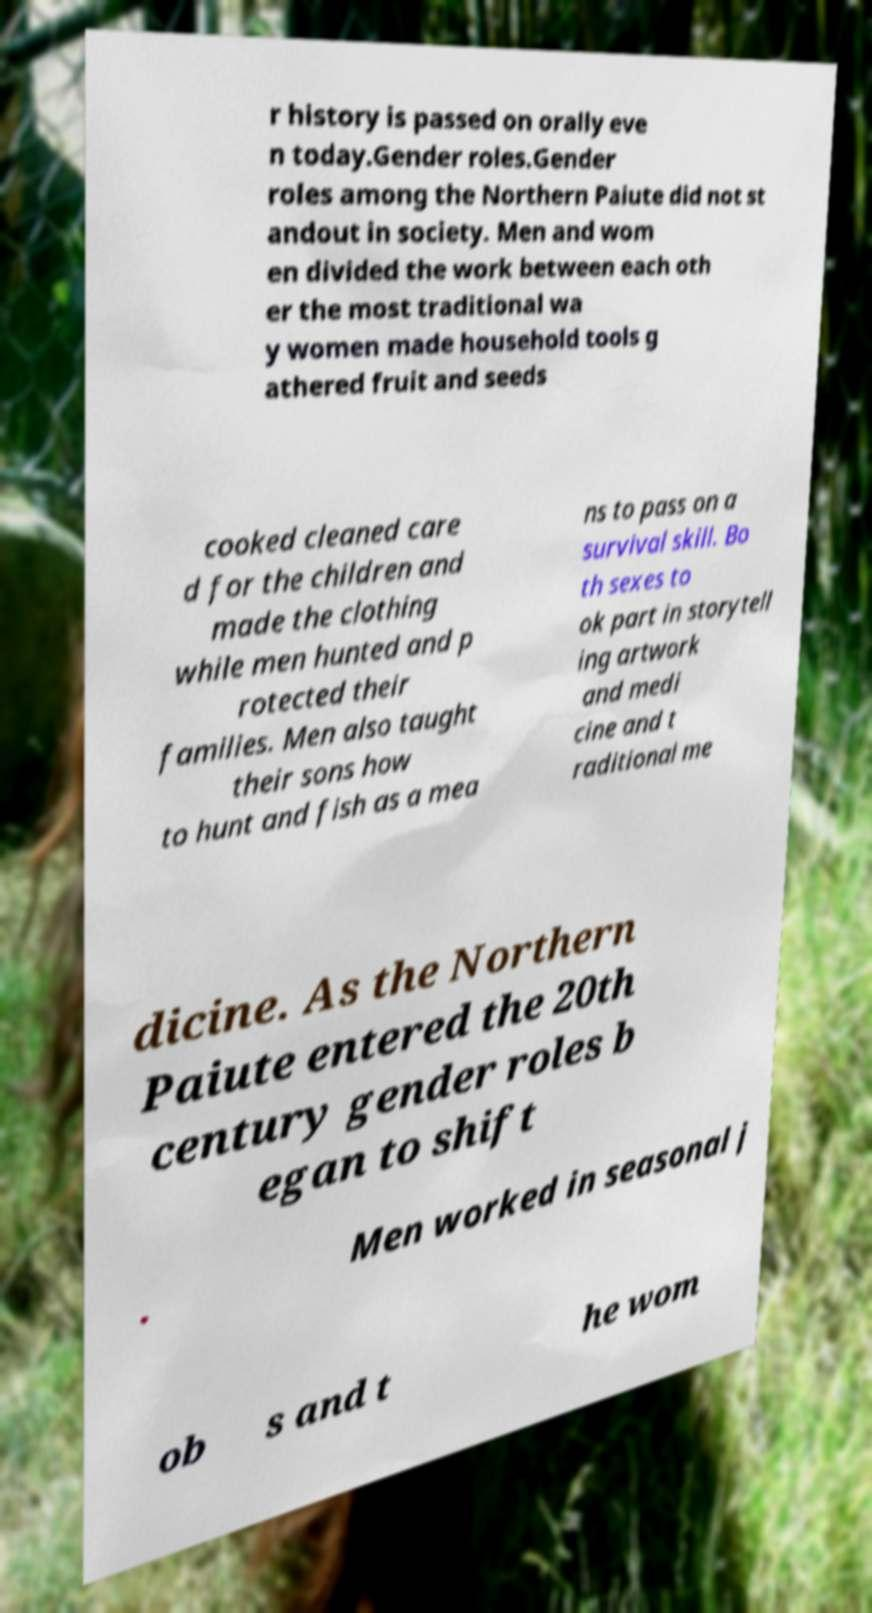Please identify and transcribe the text found in this image. r history is passed on orally eve n today.Gender roles.Gender roles among the Northern Paiute did not st andout in society. Men and wom en divided the work between each oth er the most traditional wa y women made household tools g athered fruit and seeds cooked cleaned care d for the children and made the clothing while men hunted and p rotected their families. Men also taught their sons how to hunt and fish as a mea ns to pass on a survival skill. Bo th sexes to ok part in storytell ing artwork and medi cine and t raditional me dicine. As the Northern Paiute entered the 20th century gender roles b egan to shift . Men worked in seasonal j ob s and t he wom 